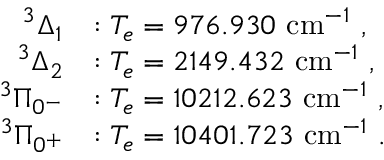<formula> <loc_0><loc_0><loc_500><loc_500>\begin{array} { r l } { ^ { 3 } \Delta _ { 1 } } & { \colon T _ { e } = 9 7 6 . 9 3 0 c m ^ { - 1 } \ , } \\ { ^ { 3 } \Delta _ { 2 } } & { \colon T _ { e } = 2 1 4 9 . 4 3 2 c m ^ { - 1 } \ , } \\ { ^ { 3 } \Pi _ { 0 ^ { - } } } & { \colon T _ { e } = 1 0 2 1 2 . 6 2 3 c m ^ { - 1 } \ , } \\ { ^ { 3 } \Pi _ { 0 ^ { + } } } & { \colon T _ { e } = 1 0 4 0 1 . 7 2 3 c m ^ { - 1 } \ . } \end{array}</formula> 